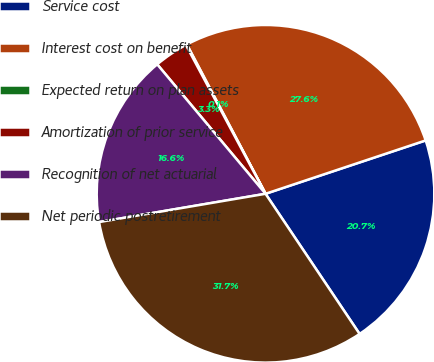Convert chart to OTSL. <chart><loc_0><loc_0><loc_500><loc_500><pie_chart><fcel>Service cost<fcel>Interest cost on benefit<fcel>Expected return on plan assets<fcel>Amortization of prior service<fcel>Recognition of net actuarial<fcel>Net periodic postretirement<nl><fcel>20.71%<fcel>27.6%<fcel>0.1%<fcel>3.27%<fcel>16.59%<fcel>31.73%<nl></chart> 